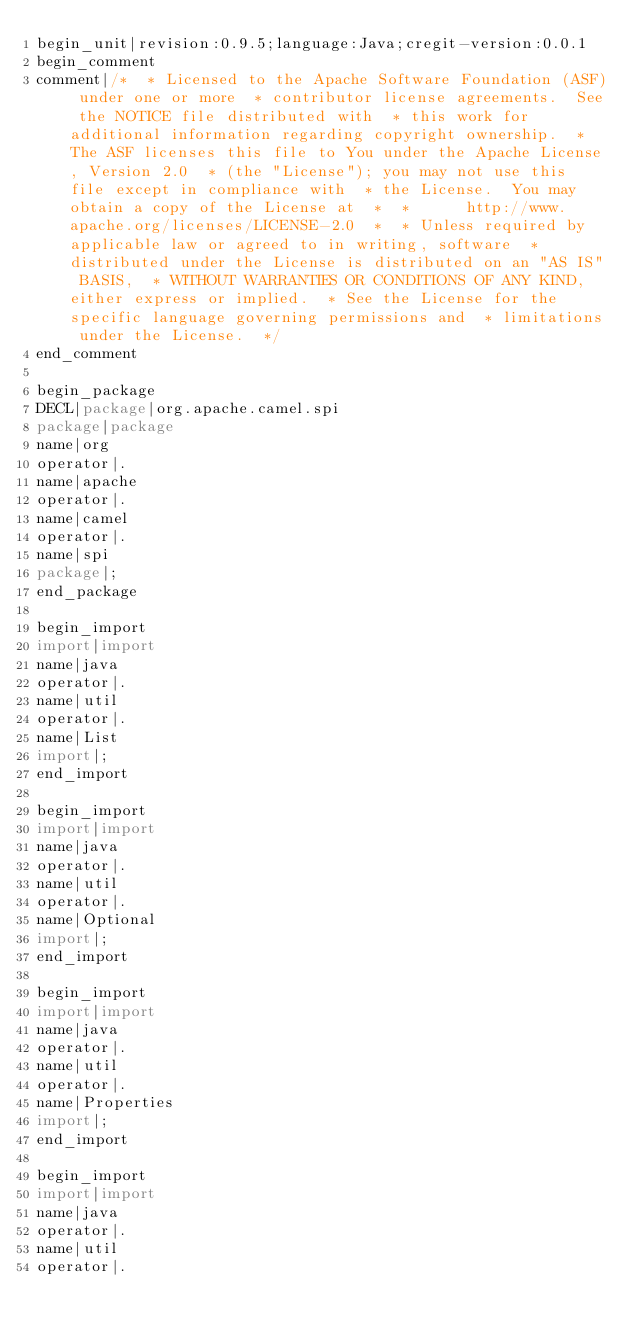<code> <loc_0><loc_0><loc_500><loc_500><_Java_>begin_unit|revision:0.9.5;language:Java;cregit-version:0.0.1
begin_comment
comment|/*  * Licensed to the Apache Software Foundation (ASF) under one or more  * contributor license agreements.  See the NOTICE file distributed with  * this work for additional information regarding copyright ownership.  * The ASF licenses this file to You under the Apache License, Version 2.0  * (the "License"); you may not use this file except in compliance with  * the License.  You may obtain a copy of the License at  *  *      http://www.apache.org/licenses/LICENSE-2.0  *  * Unless required by applicable law or agreed to in writing, software  * distributed under the License is distributed on an "AS IS" BASIS,  * WITHOUT WARRANTIES OR CONDITIONS OF ANY KIND, either express or implied.  * See the License for the specific language governing permissions and  * limitations under the License.  */
end_comment

begin_package
DECL|package|org.apache.camel.spi
package|package
name|org
operator|.
name|apache
operator|.
name|camel
operator|.
name|spi
package|;
end_package

begin_import
import|import
name|java
operator|.
name|util
operator|.
name|List
import|;
end_import

begin_import
import|import
name|java
operator|.
name|util
operator|.
name|Optional
import|;
end_import

begin_import
import|import
name|java
operator|.
name|util
operator|.
name|Properties
import|;
end_import

begin_import
import|import
name|java
operator|.
name|util
operator|.</code> 